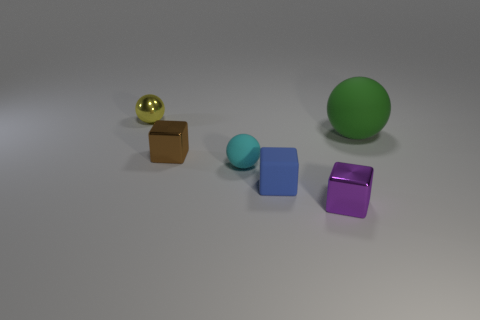Add 3 big brown matte cylinders. How many objects exist? 9 Subtract 1 purple blocks. How many objects are left? 5 Subtract all blue things. Subtract all tiny brown things. How many objects are left? 4 Add 2 small rubber spheres. How many small rubber spheres are left? 3 Add 3 cyan objects. How many cyan objects exist? 4 